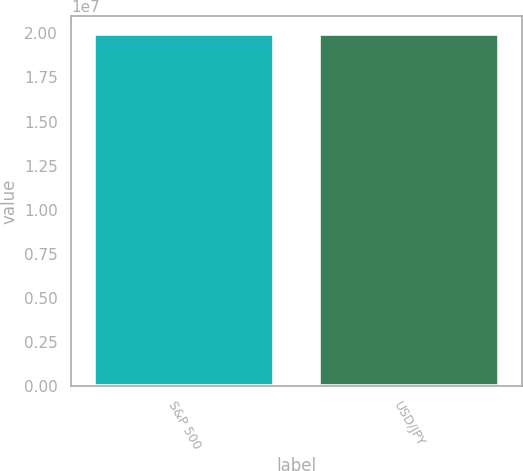Convert chart. <chart><loc_0><loc_0><loc_500><loc_500><bar_chart><fcel>S&P 500<fcel>USD/JPY<nl><fcel>1.9972e+07<fcel>1.9972e+07<nl></chart> 